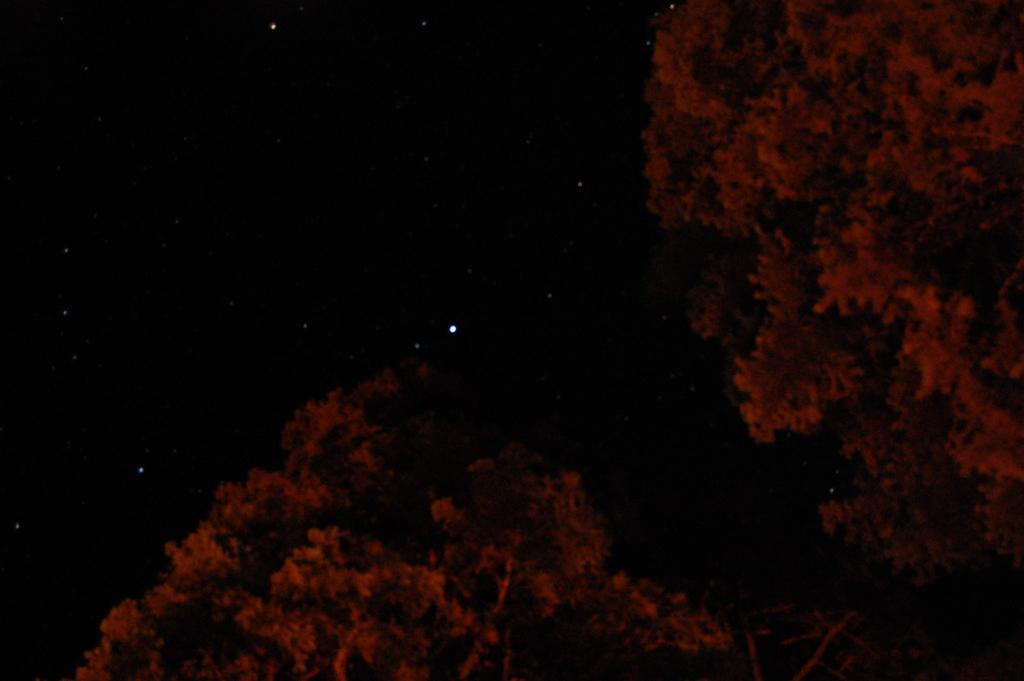In one or two sentences, can you explain what this image depicts? In the image to the bottom and right corner of the image there are trees. And in the background there is a black sky with stars. 